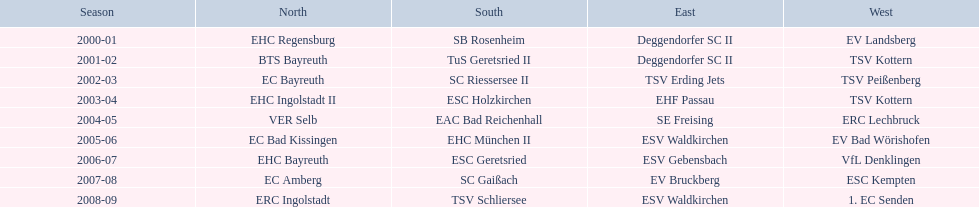Which groups performed in the north? EHC Regensburg, BTS Bayreuth, EC Bayreuth, EHC Ingolstadt II, VER Selb, EC Bad Kissingen, EHC Bayreuth, EC Amberg, ERC Ingolstadt. Among these groups, which ones took part in the 2000-2001 timeframe? EHC Regensburg. 